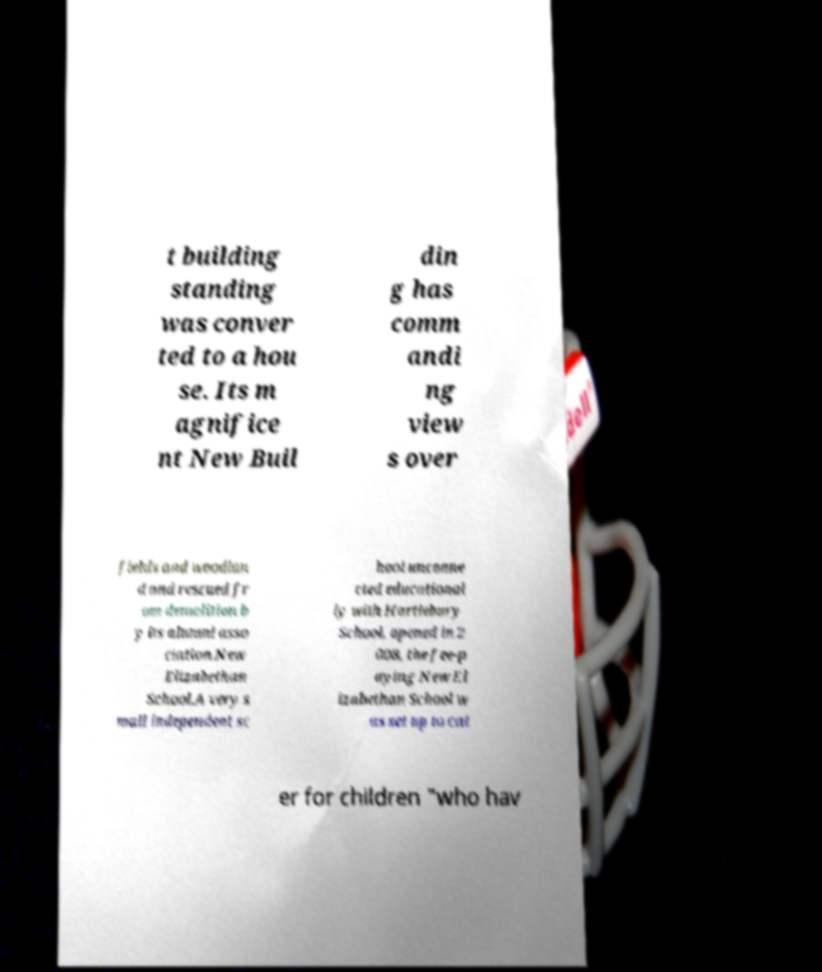Please identify and transcribe the text found in this image. t building standing was conver ted to a hou se. Its m agnifice nt New Buil din g has comm andi ng view s over fields and woodlan d and rescued fr om demolition b y its alumni asso ciation.New Elizabethan School.A very s mall independent sc hool unconne cted educational ly with Hartlebury School, opened in 2 008, the fee-p aying New El izabethan School w as set up to cat er for children "who hav 